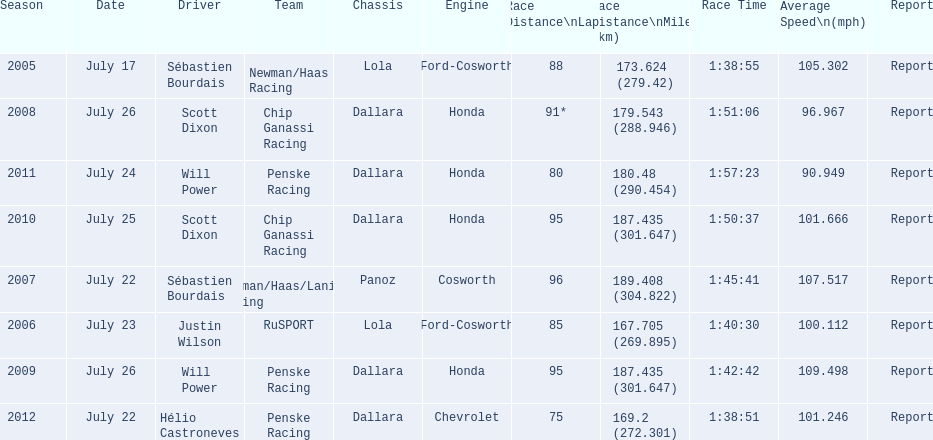What is the least amount of laps completed? 75. 